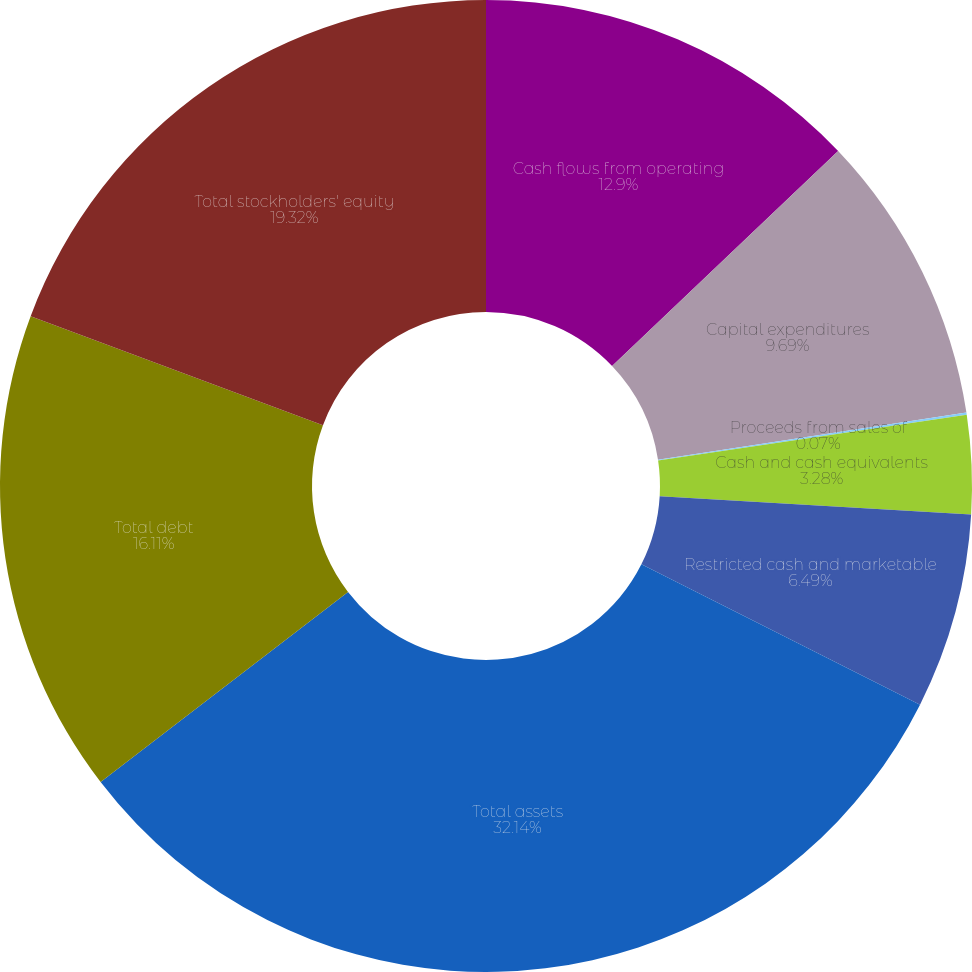Convert chart to OTSL. <chart><loc_0><loc_0><loc_500><loc_500><pie_chart><fcel>Cash flows from operating<fcel>Capital expenditures<fcel>Proceeds from sales of<fcel>Cash and cash equivalents<fcel>Restricted cash and marketable<fcel>Total assets<fcel>Total debt<fcel>Total stockholders' equity<nl><fcel>12.9%<fcel>9.69%<fcel>0.07%<fcel>3.28%<fcel>6.49%<fcel>32.15%<fcel>16.11%<fcel>19.32%<nl></chart> 